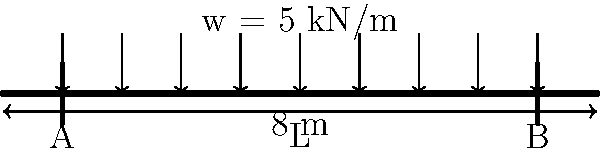As an innovative start-up founder, you're designing a prototype that requires a steel beam to support your product. Given a simply supported steel beam with a span of 8 meters and a uniformly distributed load of 5 kN/m, calculate the maximum bending moment. The beam has a rectangular cross-section with a width of 150 mm and a height of 300 mm. Assume the beam is made of S275 steel with a yield strength of 275 MPa. Let's approach this step-by-step:

1) First, we need to calculate the maximum bending moment for a simply supported beam with a uniformly distributed load. The formula for this is:

   $$M_{max} = \frac{wL^2}{8}$$

   Where:
   $w$ = uniformly distributed load
   $L$ = span of the beam

2) We have:
   $w = 5$ kN/m
   $L = 8$ m

3) Plugging these values into our formula:

   $$M_{max} = \frac{5 \times 8^2}{8} = \frac{5 \times 64}{8} = 40 \text{ kN⋅m}$$

4) To convert this to N⋅mm (which is often used in structural engineering):

   $$M_{max} = 40 \times 10^6 \text{ N⋅mm}$$

5) While not necessary for calculating the maximum bending moment, it's worth noting that the section modulus ($Z$) of the beam is:

   $$Z = \frac{bh^2}{6} = \frac{150 \times 300^2}{6} = 2,250,000 \text{ mm}^3$$

6) The maximum stress in the beam can be calculated using:

   $$\sigma_{max} = \frac{M_{max}}{Z} = \frac{40 \times 10^6}{2,250,000} = 17.78 \text{ MPa}$$

7) This is well below the yield strength of 275 MPa, indicating that the beam is safe under this loading condition.
Answer: 40 kN⋅m 